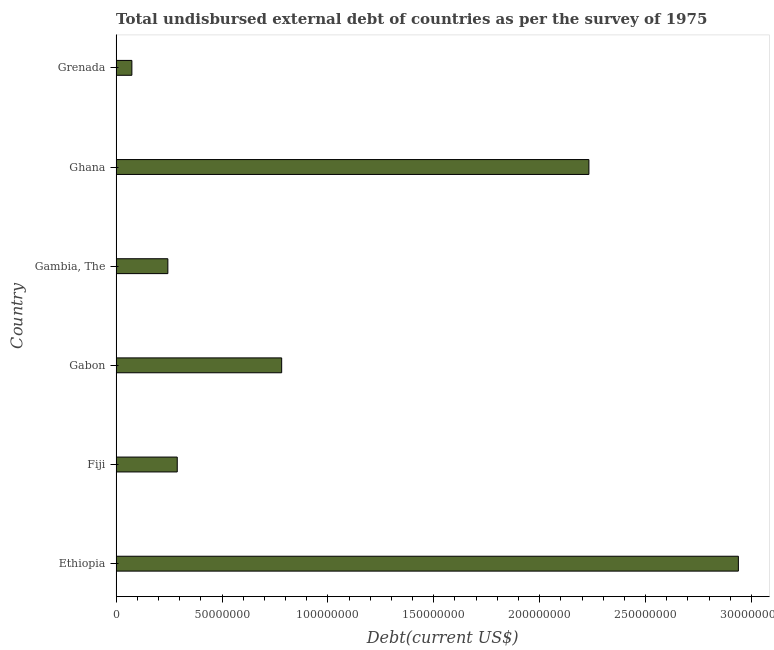Does the graph contain any zero values?
Ensure brevity in your answer.  No. What is the title of the graph?
Your response must be concise. Total undisbursed external debt of countries as per the survey of 1975. What is the label or title of the X-axis?
Offer a very short reply. Debt(current US$). What is the total debt in Fiji?
Ensure brevity in your answer.  2.89e+07. Across all countries, what is the maximum total debt?
Offer a terse response. 2.94e+08. Across all countries, what is the minimum total debt?
Your answer should be compact. 7.44e+06. In which country was the total debt maximum?
Make the answer very short. Ethiopia. In which country was the total debt minimum?
Offer a very short reply. Grenada. What is the sum of the total debt?
Provide a succinct answer. 6.56e+08. What is the difference between the total debt in Ethiopia and Gabon?
Offer a terse response. 2.16e+08. What is the average total debt per country?
Your answer should be very brief. 1.09e+08. What is the median total debt?
Offer a very short reply. 5.35e+07. In how many countries, is the total debt greater than 260000000 US$?
Your answer should be compact. 1. What is the ratio of the total debt in Fiji to that in Grenada?
Ensure brevity in your answer.  3.88. Is the total debt in Ethiopia less than that in Gambia, The?
Give a very brief answer. No. Is the difference between the total debt in Ethiopia and Grenada greater than the difference between any two countries?
Ensure brevity in your answer.  Yes. What is the difference between the highest and the second highest total debt?
Ensure brevity in your answer.  7.06e+07. What is the difference between the highest and the lowest total debt?
Ensure brevity in your answer.  2.86e+08. In how many countries, is the total debt greater than the average total debt taken over all countries?
Offer a very short reply. 2. How many bars are there?
Keep it short and to the point. 6. How many countries are there in the graph?
Ensure brevity in your answer.  6. Are the values on the major ticks of X-axis written in scientific E-notation?
Ensure brevity in your answer.  No. What is the Debt(current US$) in Ethiopia?
Provide a short and direct response. 2.94e+08. What is the Debt(current US$) of Fiji?
Ensure brevity in your answer.  2.89e+07. What is the Debt(current US$) of Gabon?
Offer a very short reply. 7.82e+07. What is the Debt(current US$) of Gambia, The?
Your response must be concise. 2.44e+07. What is the Debt(current US$) of Ghana?
Your answer should be very brief. 2.23e+08. What is the Debt(current US$) of Grenada?
Provide a succinct answer. 7.44e+06. What is the difference between the Debt(current US$) in Ethiopia and Fiji?
Give a very brief answer. 2.65e+08. What is the difference between the Debt(current US$) in Ethiopia and Gabon?
Your answer should be very brief. 2.16e+08. What is the difference between the Debt(current US$) in Ethiopia and Gambia, The?
Your answer should be compact. 2.69e+08. What is the difference between the Debt(current US$) in Ethiopia and Ghana?
Your answer should be compact. 7.06e+07. What is the difference between the Debt(current US$) in Ethiopia and Grenada?
Your answer should be compact. 2.86e+08. What is the difference between the Debt(current US$) in Fiji and Gabon?
Your answer should be compact. -4.93e+07. What is the difference between the Debt(current US$) in Fiji and Gambia, The?
Your answer should be very brief. 4.43e+06. What is the difference between the Debt(current US$) in Fiji and Ghana?
Your response must be concise. -1.94e+08. What is the difference between the Debt(current US$) in Fiji and Grenada?
Your response must be concise. 2.14e+07. What is the difference between the Debt(current US$) in Gabon and Gambia, The?
Provide a short and direct response. 5.37e+07. What is the difference between the Debt(current US$) in Gabon and Ghana?
Offer a very short reply. -1.45e+08. What is the difference between the Debt(current US$) in Gabon and Grenada?
Provide a succinct answer. 7.07e+07. What is the difference between the Debt(current US$) in Gambia, The and Ghana?
Ensure brevity in your answer.  -1.99e+08. What is the difference between the Debt(current US$) in Gambia, The and Grenada?
Your answer should be compact. 1.70e+07. What is the difference between the Debt(current US$) in Ghana and Grenada?
Offer a very short reply. 2.16e+08. What is the ratio of the Debt(current US$) in Ethiopia to that in Fiji?
Ensure brevity in your answer.  10.18. What is the ratio of the Debt(current US$) in Ethiopia to that in Gabon?
Provide a short and direct response. 3.76. What is the ratio of the Debt(current US$) in Ethiopia to that in Gambia, The?
Keep it short and to the point. 12.03. What is the ratio of the Debt(current US$) in Ethiopia to that in Ghana?
Ensure brevity in your answer.  1.32. What is the ratio of the Debt(current US$) in Ethiopia to that in Grenada?
Your response must be concise. 39.51. What is the ratio of the Debt(current US$) in Fiji to that in Gabon?
Provide a succinct answer. 0.37. What is the ratio of the Debt(current US$) in Fiji to that in Gambia, The?
Make the answer very short. 1.18. What is the ratio of the Debt(current US$) in Fiji to that in Ghana?
Ensure brevity in your answer.  0.13. What is the ratio of the Debt(current US$) in Fiji to that in Grenada?
Ensure brevity in your answer.  3.88. What is the ratio of the Debt(current US$) in Gabon to that in Gambia, The?
Your response must be concise. 3.2. What is the ratio of the Debt(current US$) in Gabon to that in Ghana?
Keep it short and to the point. 0.35. What is the ratio of the Debt(current US$) in Gabon to that in Grenada?
Make the answer very short. 10.51. What is the ratio of the Debt(current US$) in Gambia, The to that in Ghana?
Offer a very short reply. 0.11. What is the ratio of the Debt(current US$) in Gambia, The to that in Grenada?
Your response must be concise. 3.28. What is the ratio of the Debt(current US$) in Ghana to that in Grenada?
Provide a succinct answer. 30.02. 